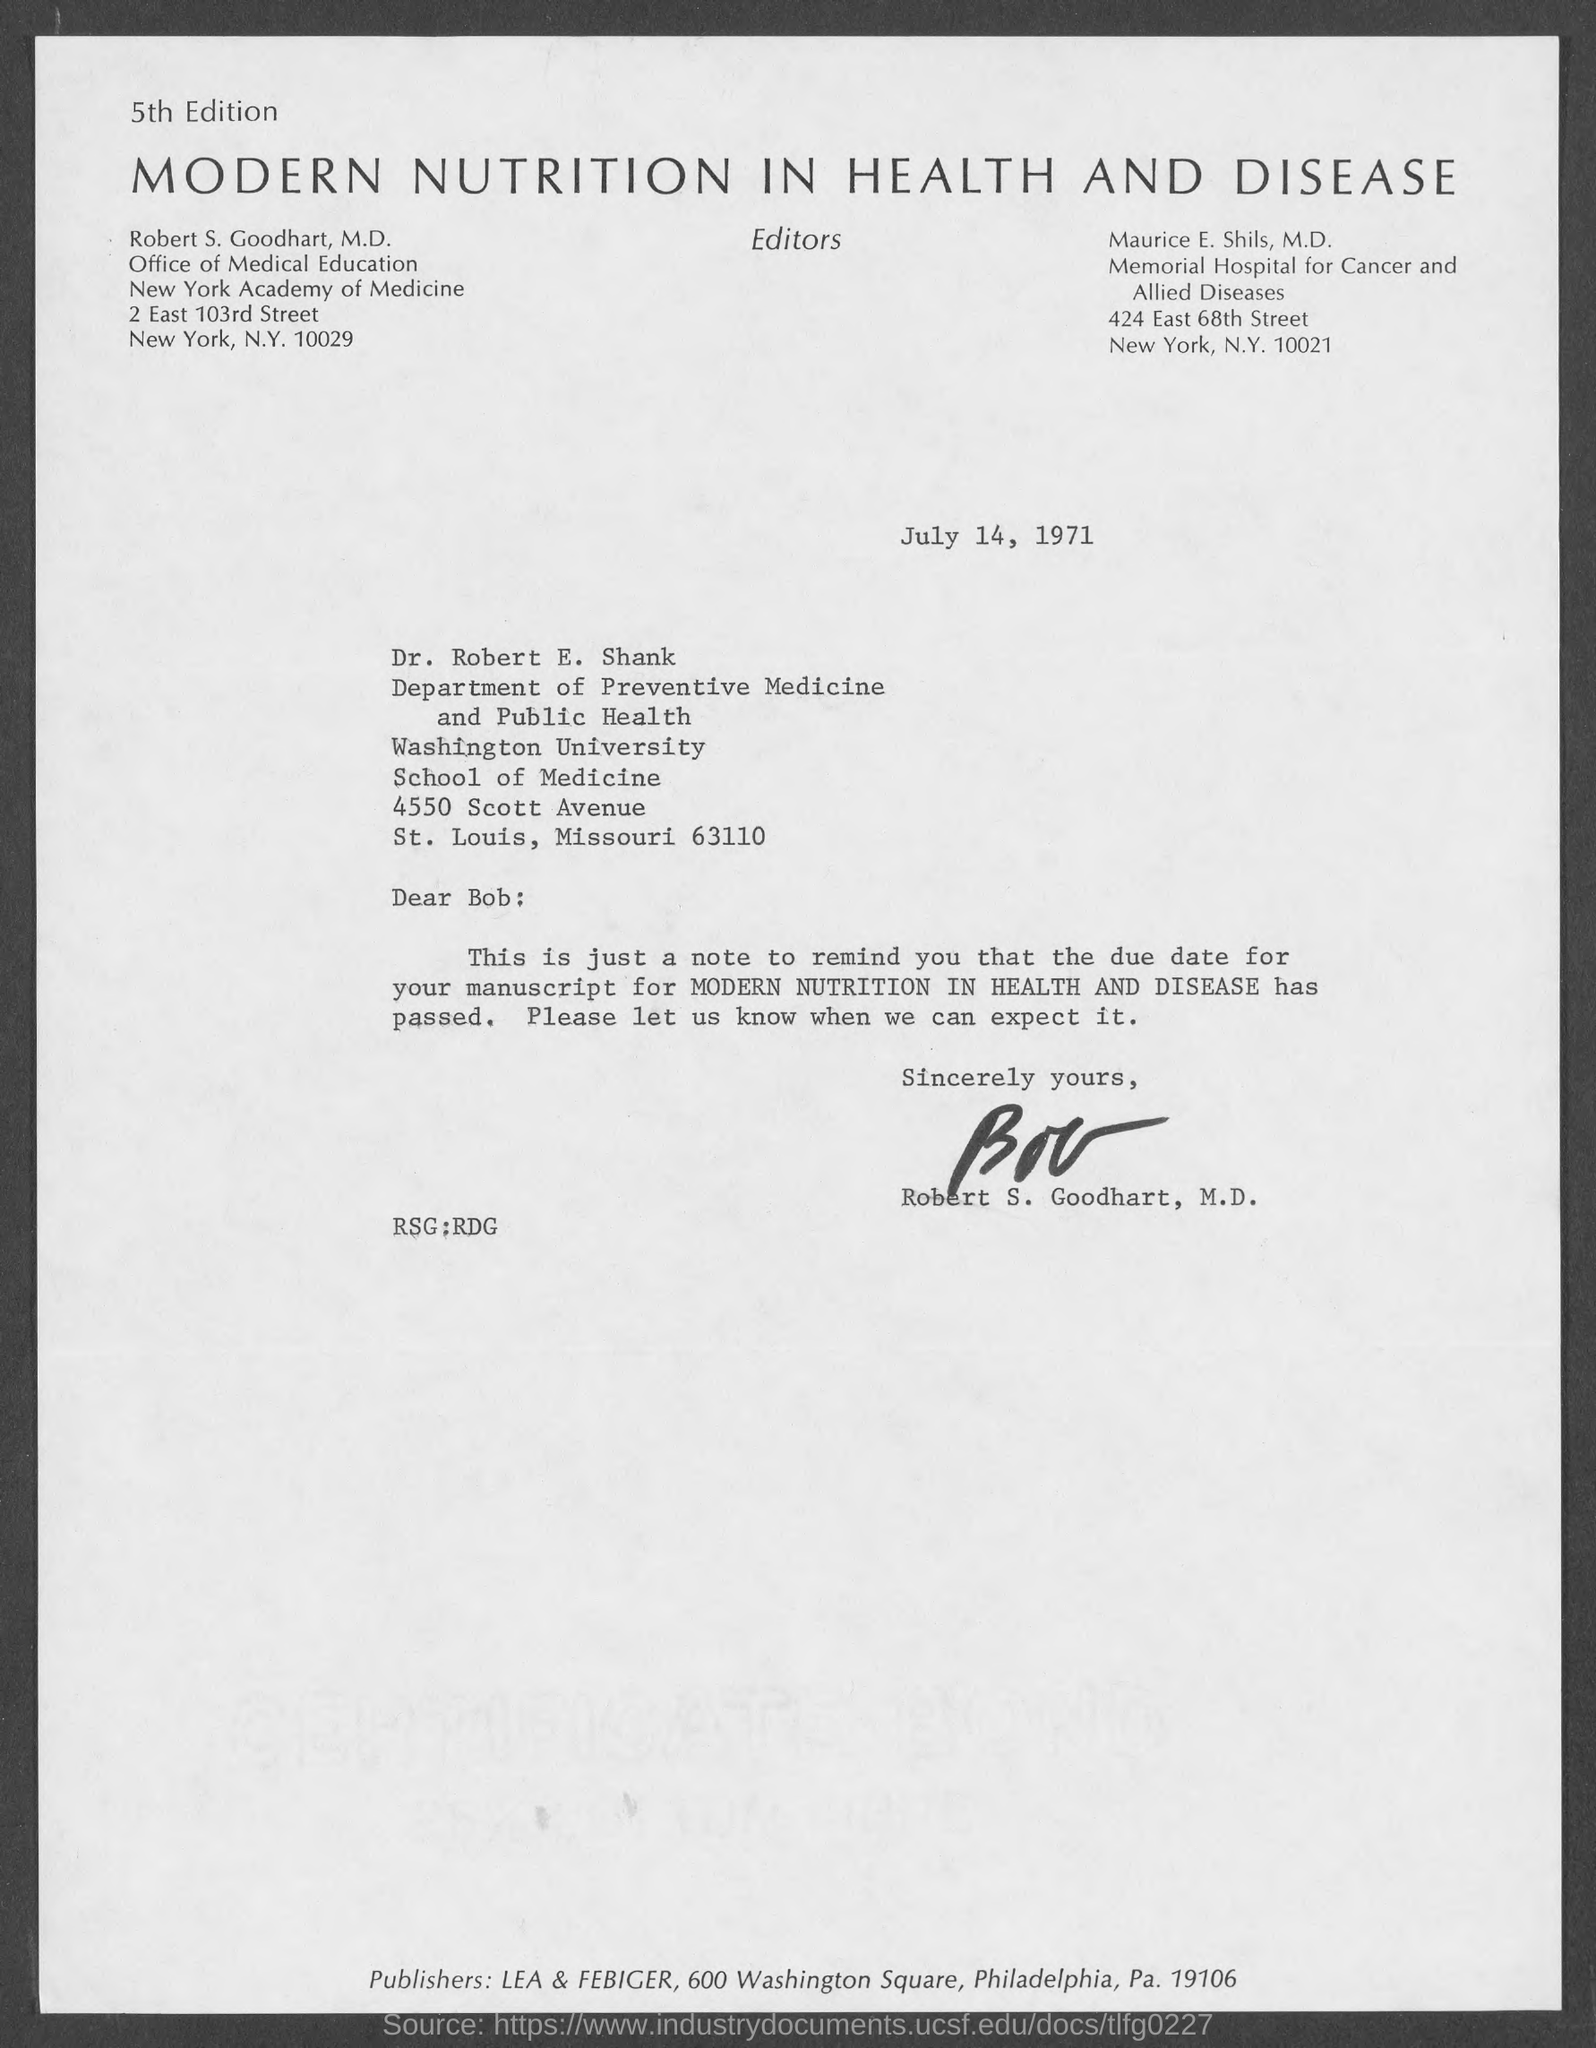What is the date on the document?
Your answer should be compact. July 14, 1971. To Whom is this letter addressed to?
Your response must be concise. Dr. Robert E. Shank. Who is this letter from?
Your answer should be compact. Robert S. Goodhart, M.D. What is the name of the manuscript that was due?
Provide a succinct answer. Modern Nutrition in Health and Disease. 